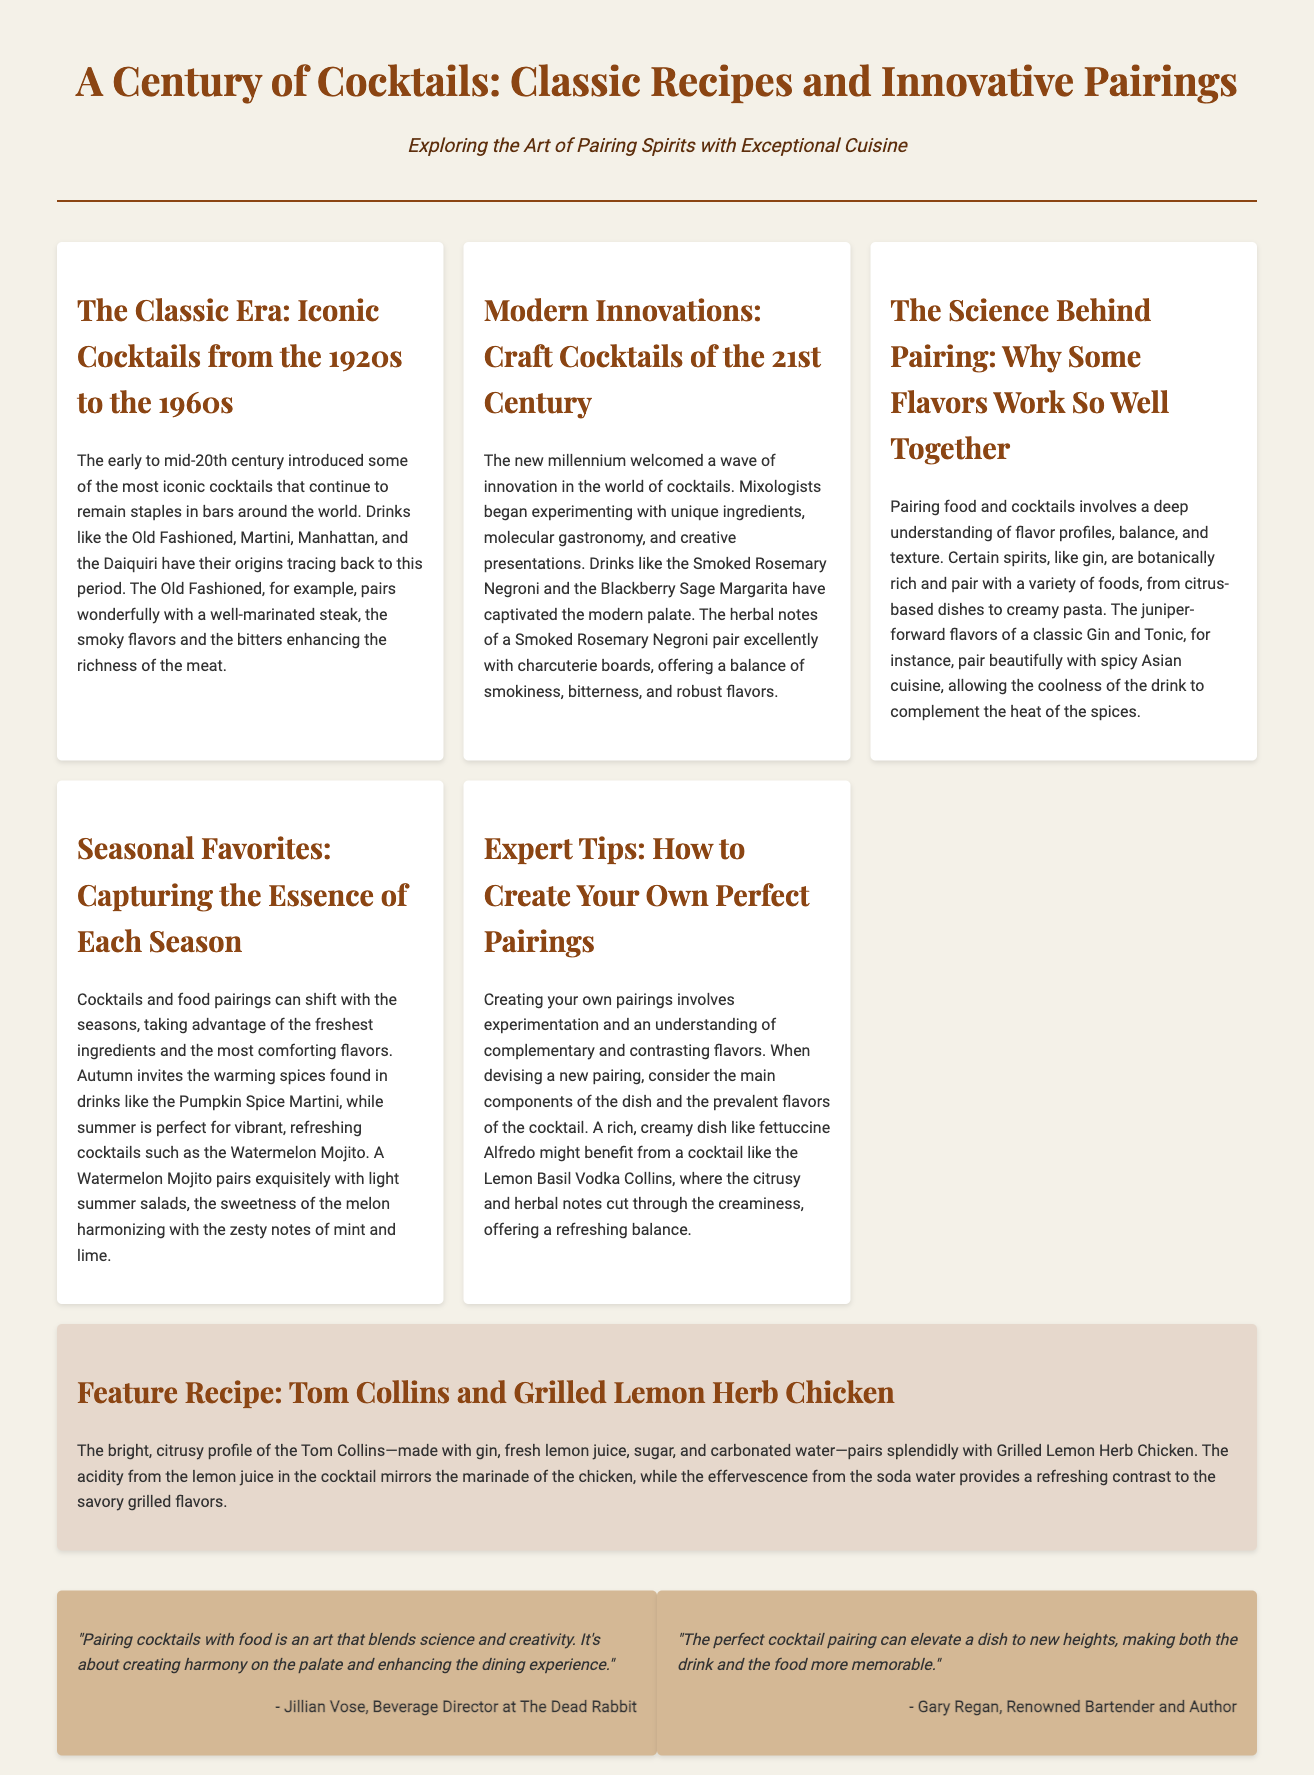What are some iconic cocktails from the 1920s? The document lists cocktails from the 1920s including the Old Fashioned, Martini, Manhattan, and Daiquiri.
Answer: Old Fashioned, Martini, Manhattan, Daiquiri What is the main ingredient in a Tom Collins? The Tom Collins is made with gin, fresh lemon juice, sugar, and carbonated water, with gin being the primary spirit.
Answer: Gin Which cocktail pairs well with charcuterie boards? The Smoked Rosemary Negroni is mentioned as pairing excellently with charcuterie boards.
Answer: Smoked Rosemary Negroni What is the seasonal cocktail mentioned for summer? The Watermelon Mojito is highlighted as a refreshing cocktail for the summer season.
Answer: Watermelon Mojito Who is the Beverage Director at The Dead Rabbit? Jillian Vose is the Beverage Director at The Dead Rabbit, as per the quotes section.
Answer: Jillian Vose What does the science of pairing explore? The science behind pairing food and cocktails involves understanding flavor profiles, balance, and texture.
Answer: Flavor profiles, balance, and texture What type of dish pairs well with the Lemon Basil Vodka Collins? A rich, creamy dish like fettuccine Alfredo is suggested to pair well with the Lemon Basil Vodka Collins.
Answer: Fettuccine Alfredo What is the main flavor profile of the featured cocktail? The Tom Collins has a bright, citrusy profile, primarily due to the fresh lemon juice.
Answer: Citrusy What period is referred to as the Classic Era in cocktails? The Classic Era refers to the time from the 1920s to the 1960s in the context of cocktail history.
Answer: 1920s to 1960s 